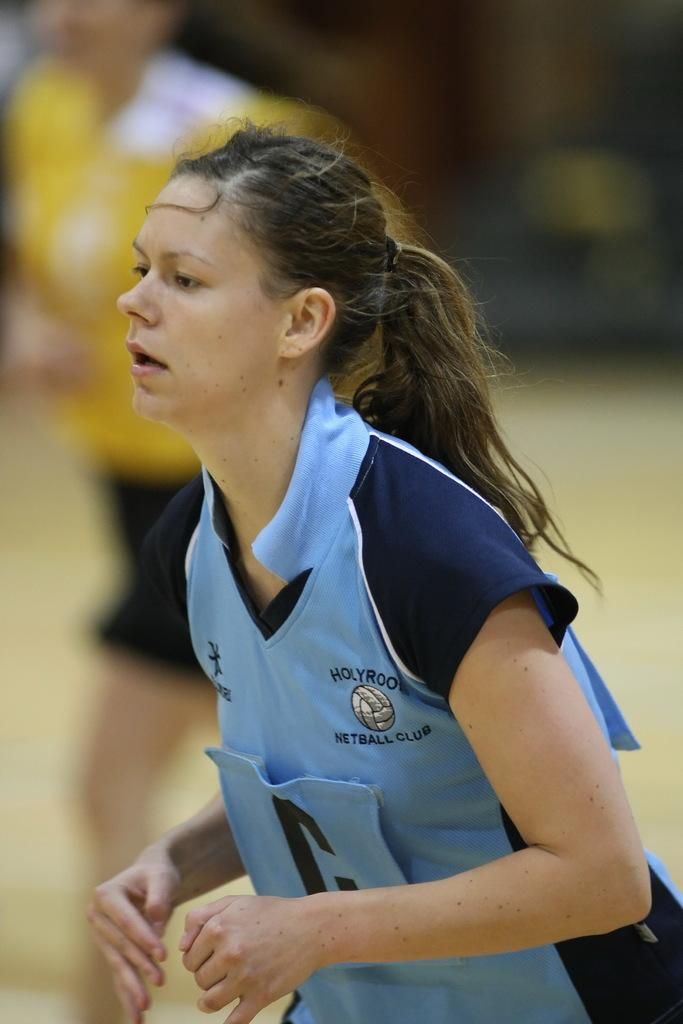<image>
Give a short and clear explanation of the subsequent image. The girl is part of the netball club at her school 